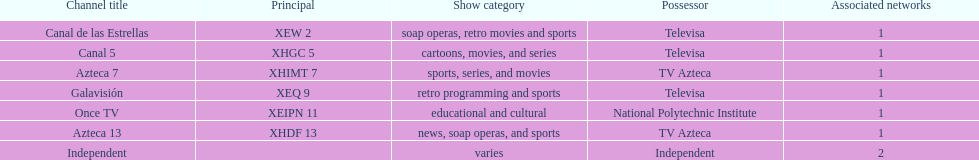How many networks does televisa own? 3. 